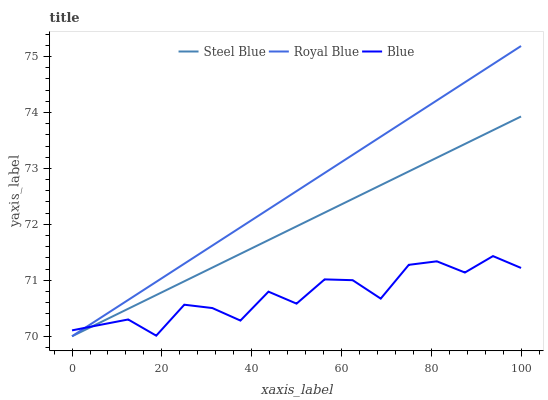Does Blue have the minimum area under the curve?
Answer yes or no. Yes. Does Royal Blue have the maximum area under the curve?
Answer yes or no. Yes. Does Steel Blue have the minimum area under the curve?
Answer yes or no. No. Does Steel Blue have the maximum area under the curve?
Answer yes or no. No. Is Steel Blue the smoothest?
Answer yes or no. Yes. Is Blue the roughest?
Answer yes or no. Yes. Is Royal Blue the smoothest?
Answer yes or no. No. Is Royal Blue the roughest?
Answer yes or no. No. Does Royal Blue have the lowest value?
Answer yes or no. Yes. Does Royal Blue have the highest value?
Answer yes or no. Yes. Does Steel Blue have the highest value?
Answer yes or no. No. Does Royal Blue intersect Blue?
Answer yes or no. Yes. Is Royal Blue less than Blue?
Answer yes or no. No. Is Royal Blue greater than Blue?
Answer yes or no. No. 